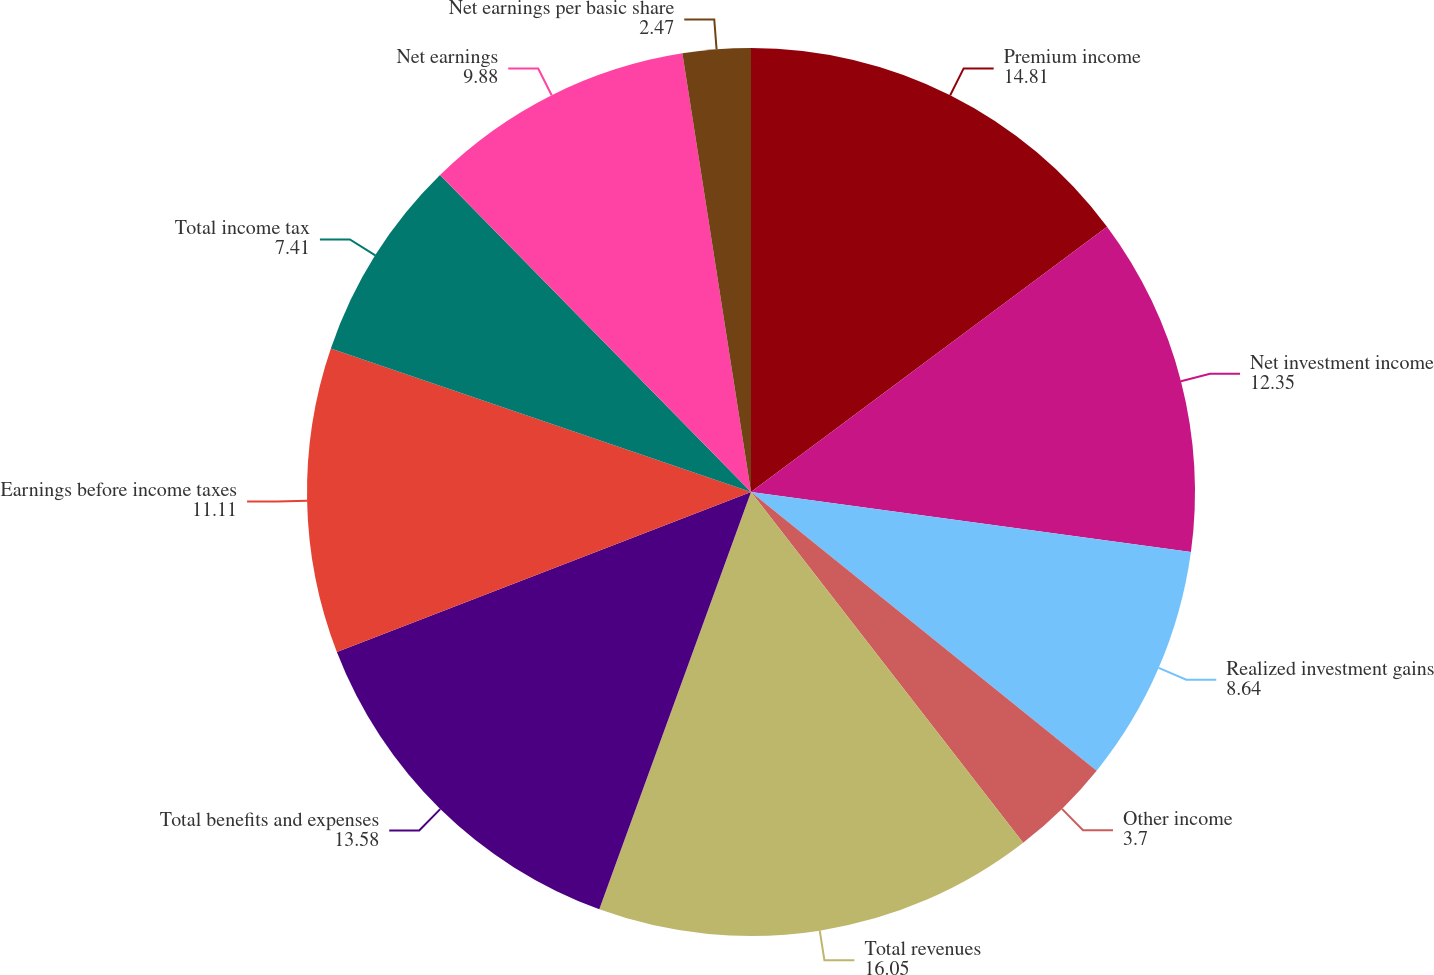Convert chart. <chart><loc_0><loc_0><loc_500><loc_500><pie_chart><fcel>Premium income<fcel>Net investment income<fcel>Realized investment gains<fcel>Other income<fcel>Total revenues<fcel>Total benefits and expenses<fcel>Earnings before income taxes<fcel>Total income tax<fcel>Net earnings<fcel>Net earnings per basic share<nl><fcel>14.81%<fcel>12.35%<fcel>8.64%<fcel>3.7%<fcel>16.05%<fcel>13.58%<fcel>11.11%<fcel>7.41%<fcel>9.88%<fcel>2.47%<nl></chart> 